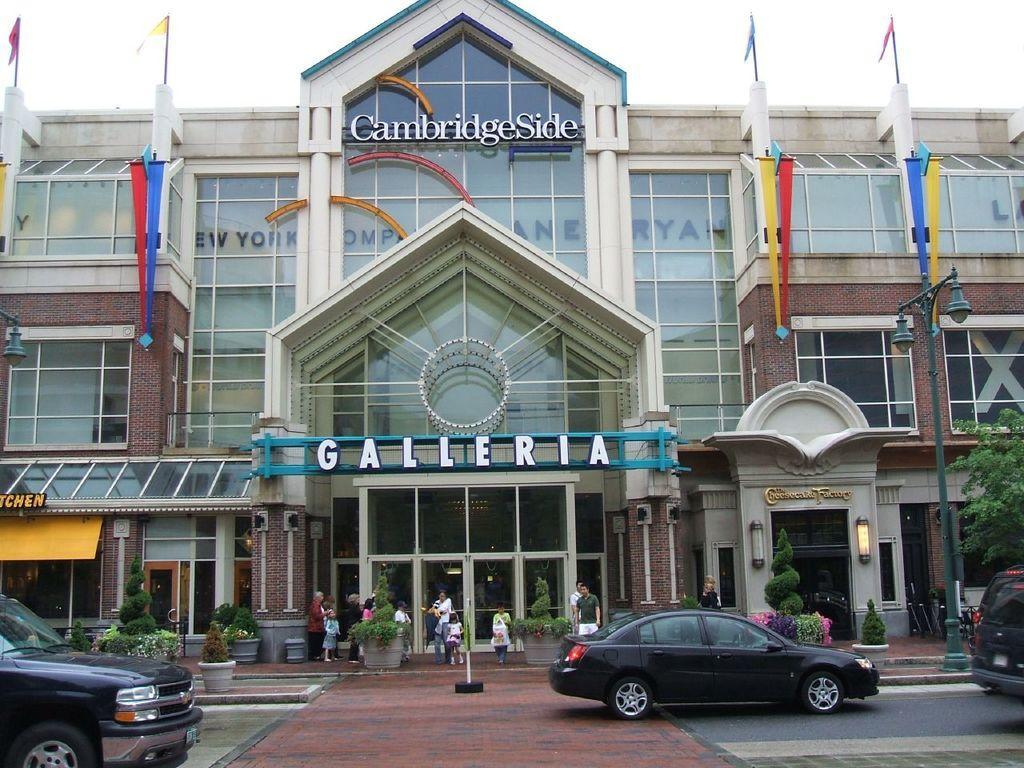Could you give a brief overview of what you see in this image? There are cars, plants people are present. There is a pole, buildings and flags. 